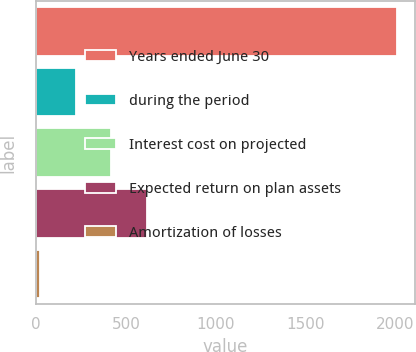<chart> <loc_0><loc_0><loc_500><loc_500><bar_chart><fcel>Years ended June 30<fcel>during the period<fcel>Interest cost on projected<fcel>Expected return on plan assets<fcel>Amortization of losses<nl><fcel>2011<fcel>219.19<fcel>418.28<fcel>617.37<fcel>20.1<nl></chart> 